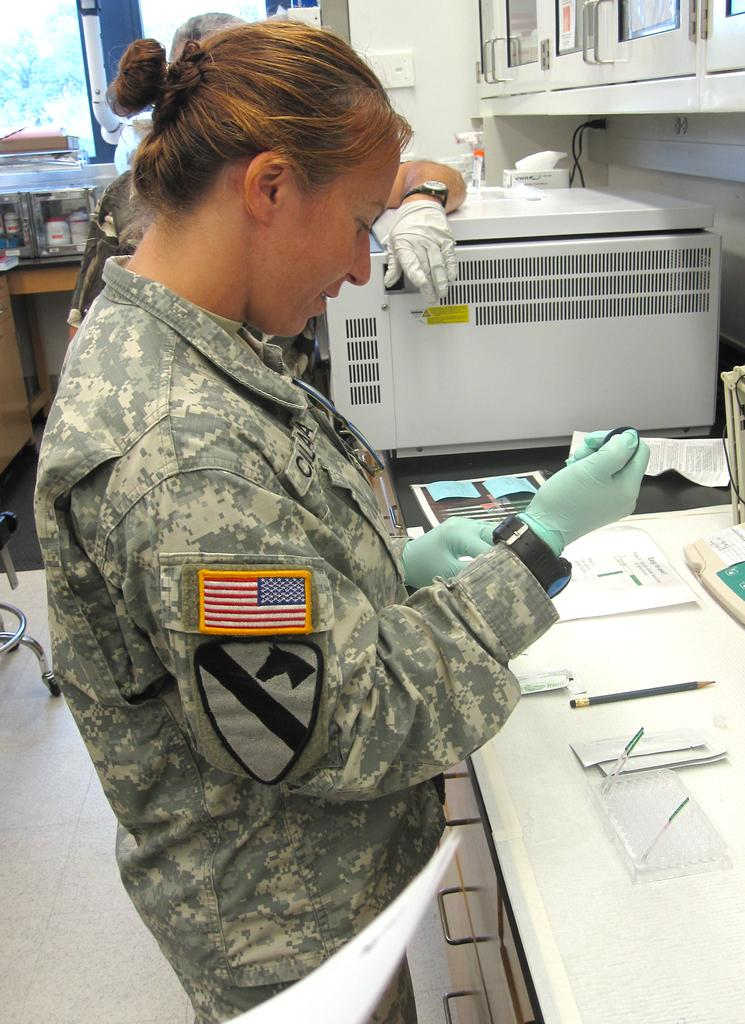How many people are in the image? There are two people standing in the image. What surface are the people standing on? The people are standing on the floor. What stationary object can be seen in the image? There is a pencil in the image. What type of writing material is present in the image? There are papers in the image. What machine is visible in the image? There is a machine in the image. What type of storage furniture is present in the image? There are cupboards in the image. What type of electrical connections are present in the image? Cables are present in the image. What other objects can be seen in the image? There are other objects in the image. What type of butter is being used to grease the jail bars in the image? There is no jail or butter present in the image. 